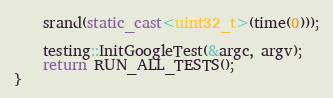<code> <loc_0><loc_0><loc_500><loc_500><_C++_>    srand(static_cast<uint32_t>(time(0)));

    testing::InitGoogleTest(&argc, argv);
    return RUN_ALL_TESTS();
}
</code> 